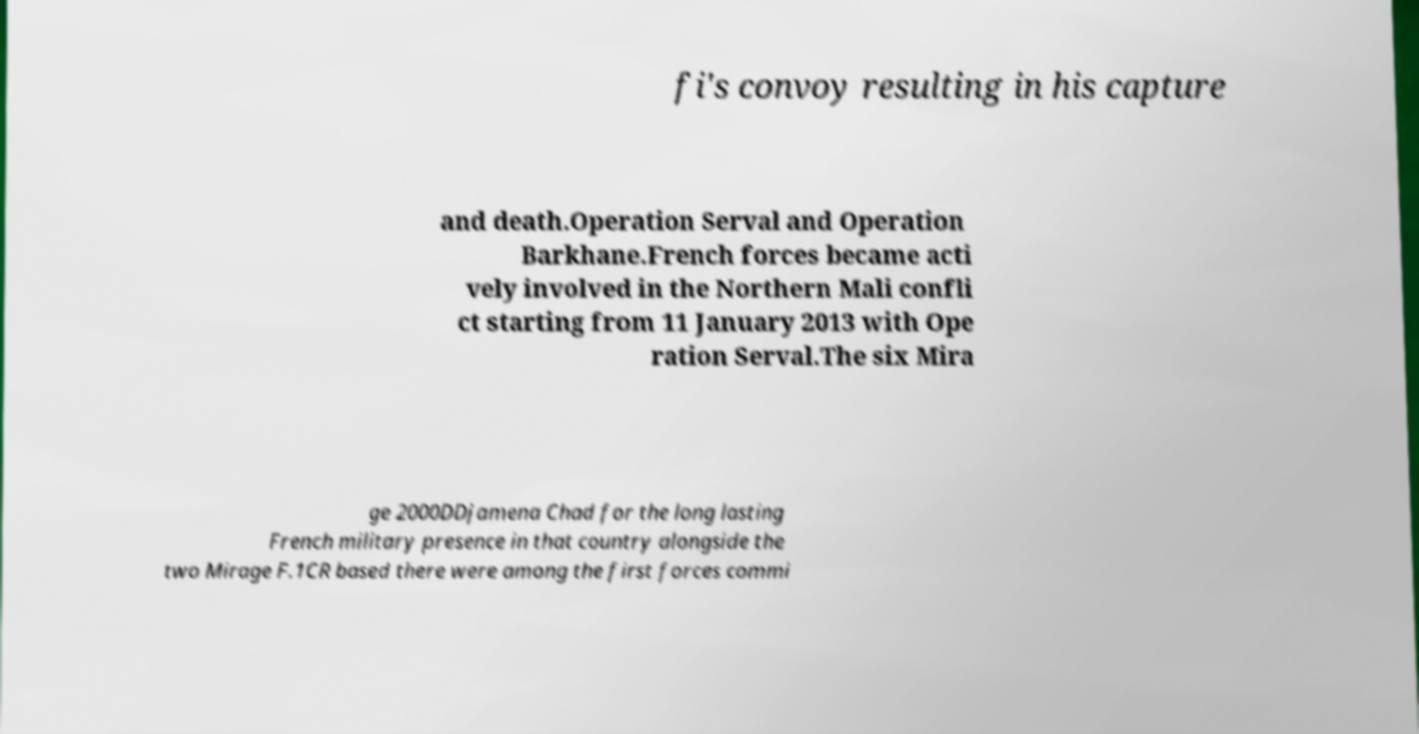What messages or text are displayed in this image? I need them in a readable, typed format. fi's convoy resulting in his capture and death.Operation Serval and Operation Barkhane.French forces became acti vely involved in the Northern Mali confli ct starting from 11 January 2013 with Ope ration Serval.The six Mira ge 2000DDjamena Chad for the long lasting French military presence in that country alongside the two Mirage F.1CR based there were among the first forces commi 